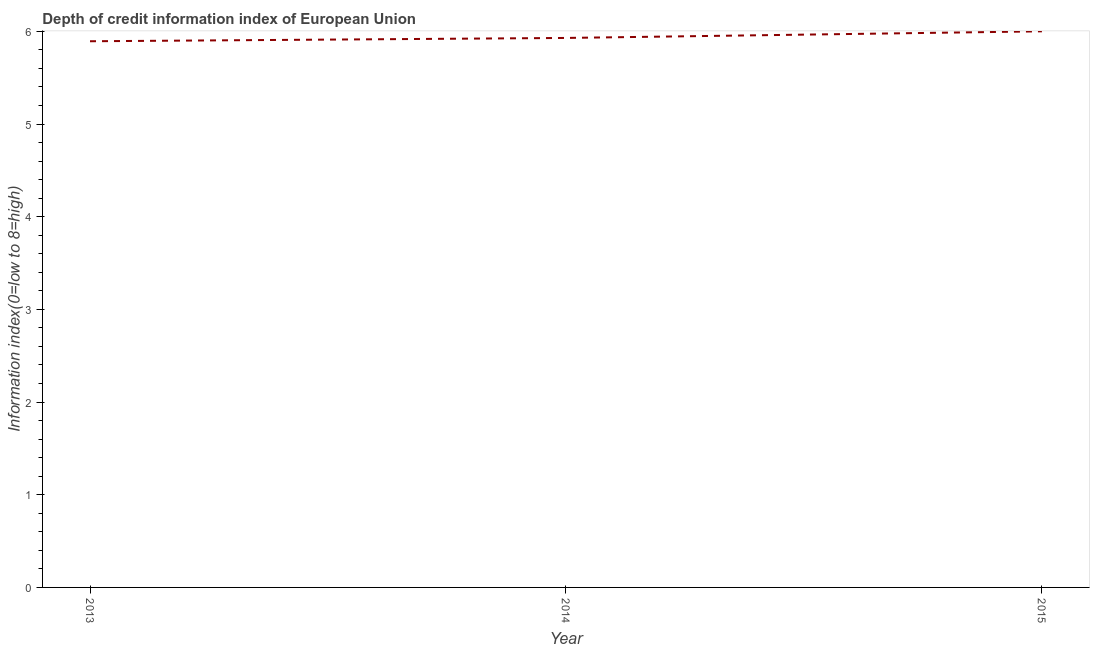Across all years, what is the maximum depth of credit information index?
Provide a short and direct response. 6. Across all years, what is the minimum depth of credit information index?
Provide a short and direct response. 5.89. In which year was the depth of credit information index maximum?
Give a very brief answer. 2015. In which year was the depth of credit information index minimum?
Ensure brevity in your answer.  2013. What is the sum of the depth of credit information index?
Offer a terse response. 17.82. What is the difference between the depth of credit information index in 2014 and 2015?
Ensure brevity in your answer.  -0.07. What is the average depth of credit information index per year?
Your answer should be compact. 5.94. What is the median depth of credit information index?
Ensure brevity in your answer.  5.93. What is the ratio of the depth of credit information index in 2014 to that in 2015?
Ensure brevity in your answer.  0.99. Is the depth of credit information index in 2014 less than that in 2015?
Give a very brief answer. Yes. What is the difference between the highest and the second highest depth of credit information index?
Offer a very short reply. 0.07. What is the difference between the highest and the lowest depth of credit information index?
Keep it short and to the point. 0.11. Does the depth of credit information index monotonically increase over the years?
Make the answer very short. Yes. How many lines are there?
Your response must be concise. 1. Are the values on the major ticks of Y-axis written in scientific E-notation?
Offer a very short reply. No. Does the graph contain any zero values?
Offer a terse response. No. Does the graph contain grids?
Your answer should be compact. No. What is the title of the graph?
Provide a short and direct response. Depth of credit information index of European Union. What is the label or title of the Y-axis?
Your answer should be very brief. Information index(0=low to 8=high). What is the Information index(0=low to 8=high) in 2013?
Your answer should be compact. 5.89. What is the Information index(0=low to 8=high) of 2014?
Offer a very short reply. 5.93. What is the Information index(0=low to 8=high) of 2015?
Your response must be concise. 6. What is the difference between the Information index(0=low to 8=high) in 2013 and 2014?
Offer a terse response. -0.04. What is the difference between the Information index(0=low to 8=high) in 2013 and 2015?
Offer a terse response. -0.11. What is the difference between the Information index(0=low to 8=high) in 2014 and 2015?
Provide a short and direct response. -0.07. What is the ratio of the Information index(0=low to 8=high) in 2014 to that in 2015?
Offer a very short reply. 0.99. 